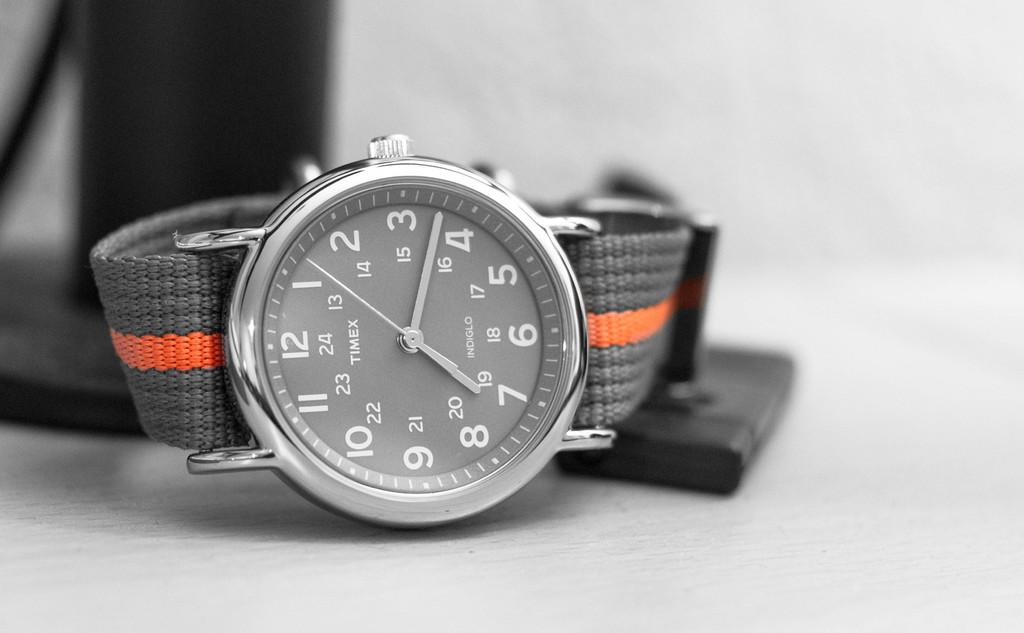<image>
Describe the image concisely. Gray and white watch with the word TIMEX on the face. 